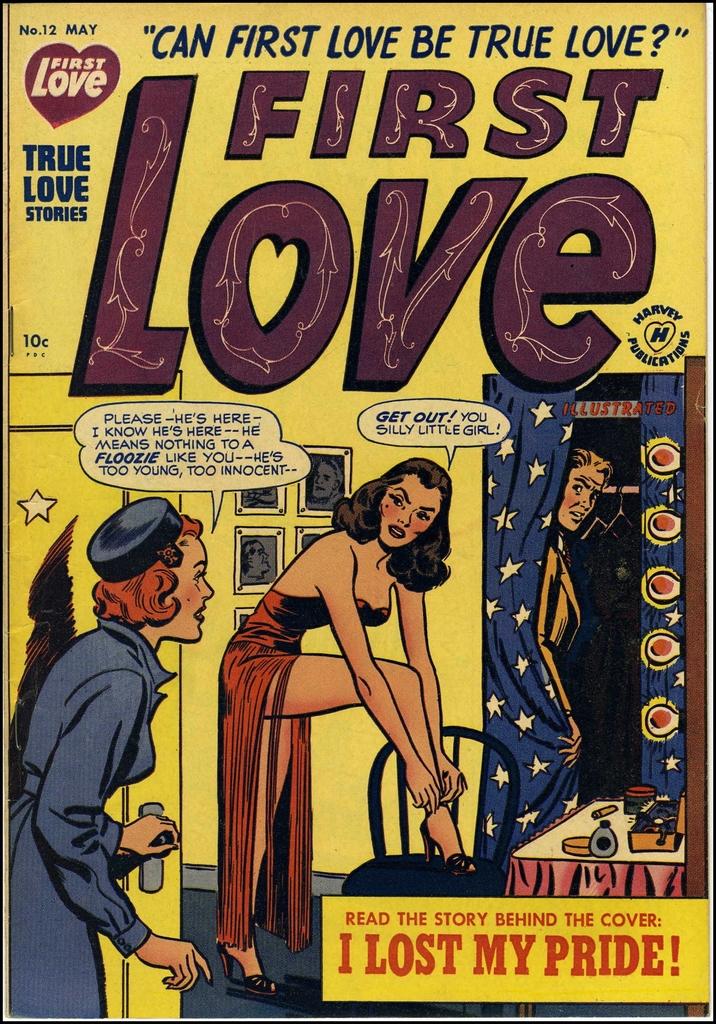What is the name of this publication?
Offer a very short reply. First love. 